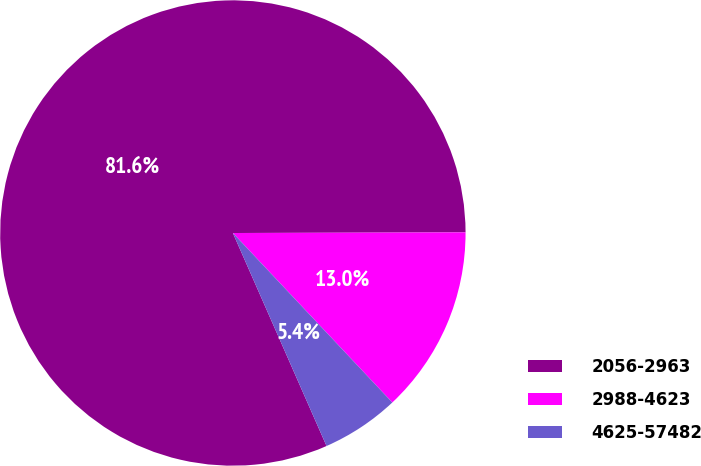Convert chart. <chart><loc_0><loc_0><loc_500><loc_500><pie_chart><fcel>2056-2963<fcel>2988-4623<fcel>4625-57482<nl><fcel>81.55%<fcel>13.03%<fcel>5.42%<nl></chart> 